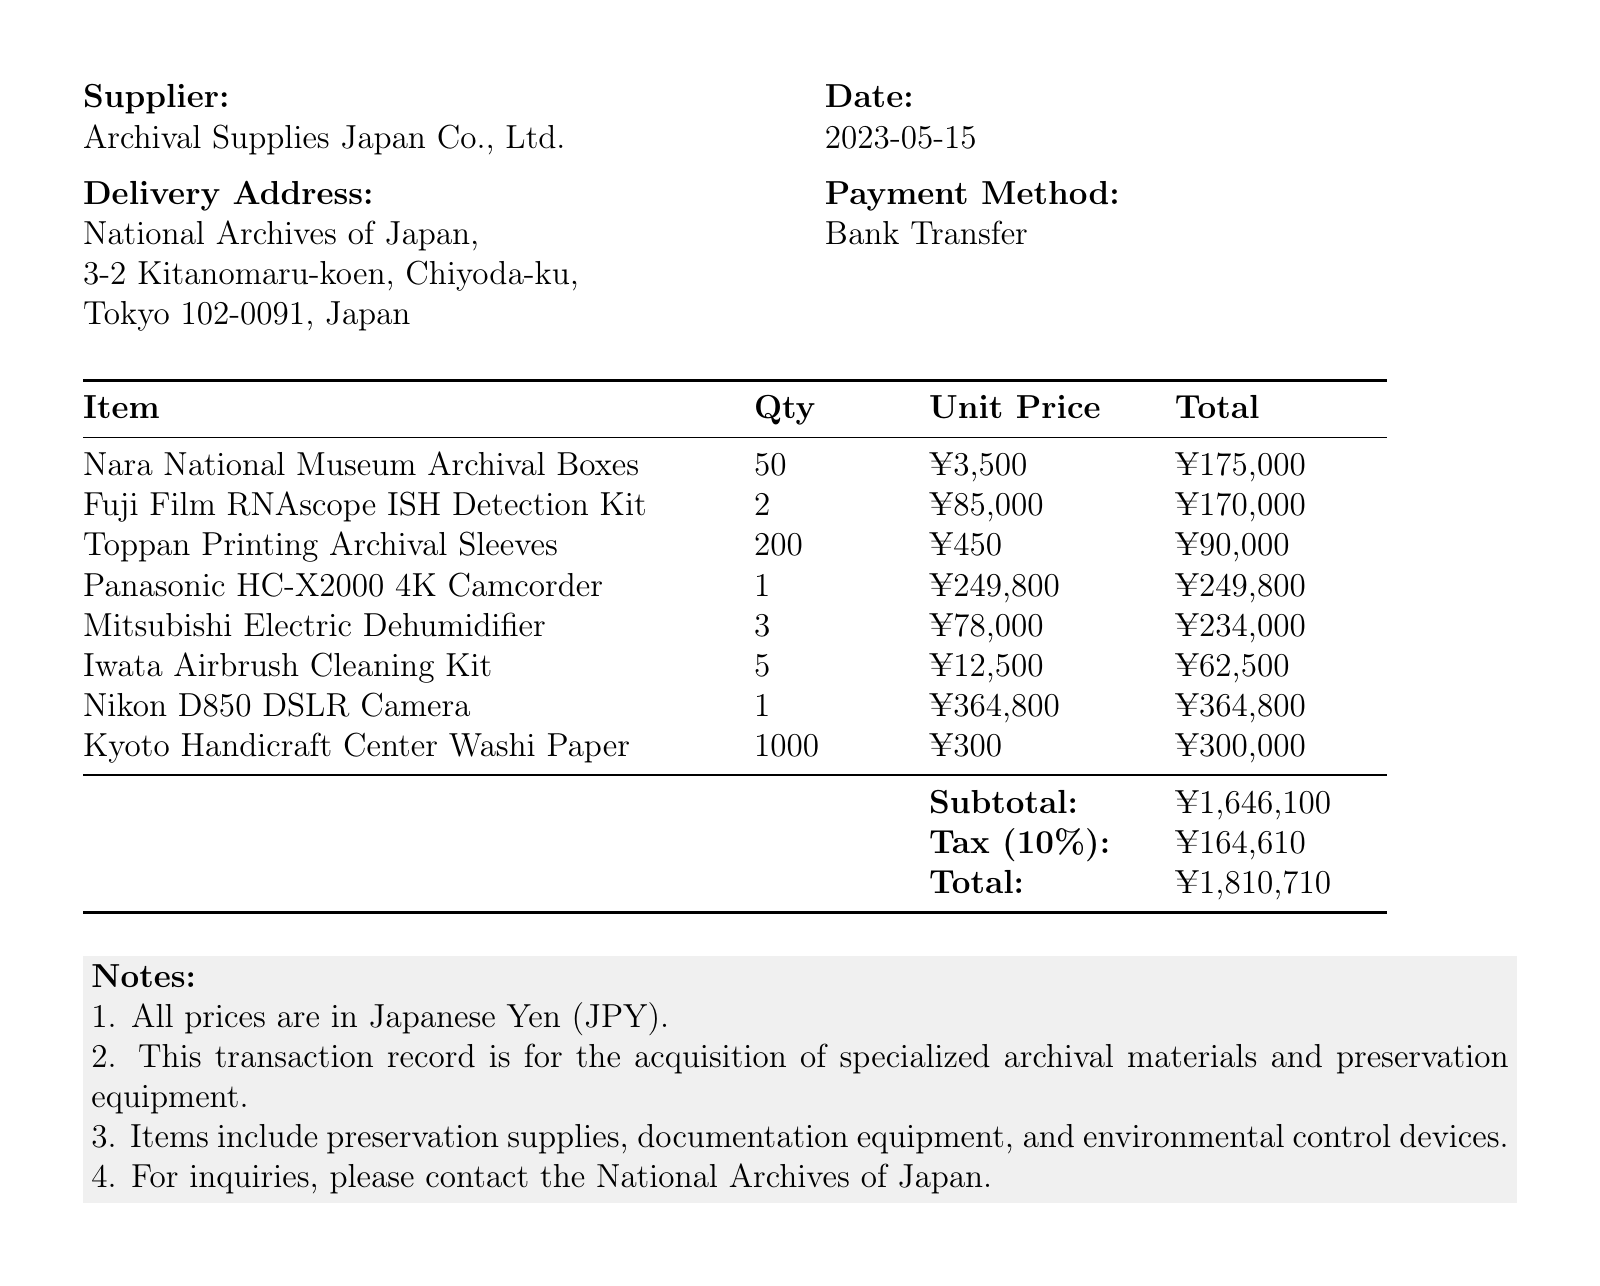What is the transaction date? The transaction date is the date on which the transaction occurred, as stated in the document.
Answer: 2023-05-15 Who is the supplier? The supplier is the entity that provided the items listed in the transaction, mentioned in the document.
Answer: Archival Supplies Japan Co., Ltd What is the order number? The order number is a unique identifier for the transaction, clearly indicated in the document.
Answer: ASJ-2023-0515 How many Nara National Museum Archival Boxes were purchased? The quantity of Nara National Museum Archival Boxes is specified in the item list of the document.
Answer: 50 What is the total amount, including tax? The total amount is calculated as the subtotal plus tax, presented at the end of the transaction document.
Answer: ¥1,810,710 What type of equipment is the Panasonic HC-X2000? This question involves reasoning about the item description provided for the Panasonic HC-X2000 in the document.
Answer: Camcorder How many items are listed in the transaction? The number of items can be counted from the itemized list in the document.
Answer: 8 What is the tax rate applied in this transaction? The tax rate is specifically mentioned in the document alongside the tax amount.
Answer: 10% What is the delivery address? The delivery address is the location where the purchased items are to be delivered, specified in the document.
Answer: National Archives of Japan, 3-2 Kitanomaru-koen, Chiyoda-ku, Tokyo 102-0091, Japan 